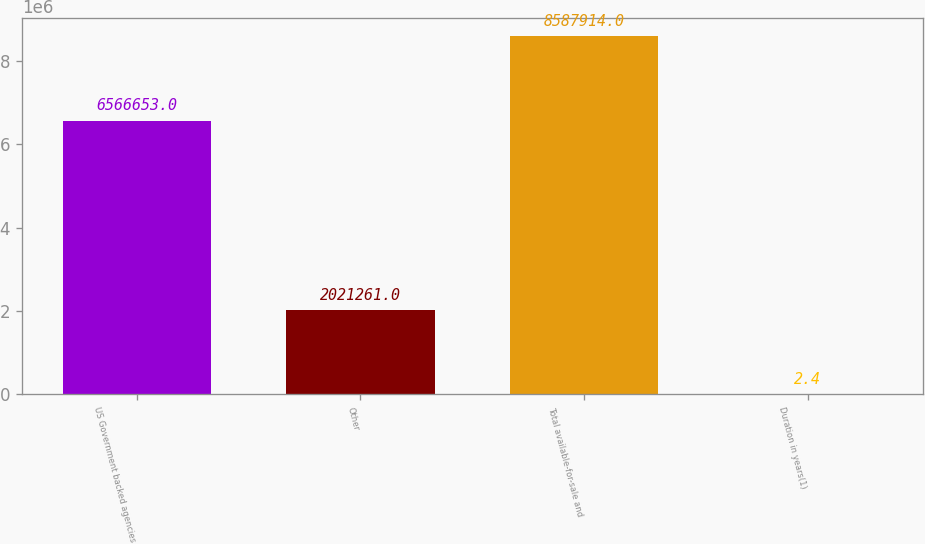Convert chart to OTSL. <chart><loc_0><loc_0><loc_500><loc_500><bar_chart><fcel>US Government backed agencies<fcel>Other<fcel>Total available-for-sale and<fcel>Duration in years(1)<nl><fcel>6.56665e+06<fcel>2.02126e+06<fcel>8.58791e+06<fcel>2.4<nl></chart> 